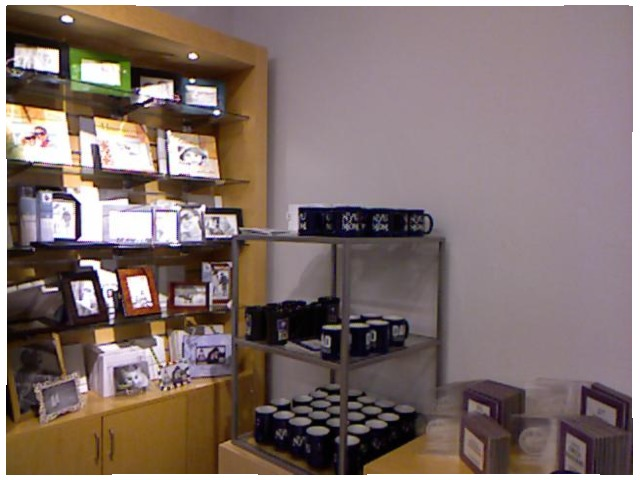<image>
Is there a book on the shelf? Yes. Looking at the image, I can see the book is positioned on top of the shelf, with the shelf providing support. Where is the frames in relation to the cupboard? Is it on the cupboard? Yes. Looking at the image, I can see the frames is positioned on top of the cupboard, with the cupboard providing support. Where is the mug in relation to the shelf? Is it on the shelf? No. The mug is not positioned on the shelf. They may be near each other, but the mug is not supported by or resting on top of the shelf. Is there a frame to the right of the mug? No. The frame is not to the right of the mug. The horizontal positioning shows a different relationship. Where is the cup in relation to the shelf? Is it in the shelf? Yes. The cup is contained within or inside the shelf, showing a containment relationship. 